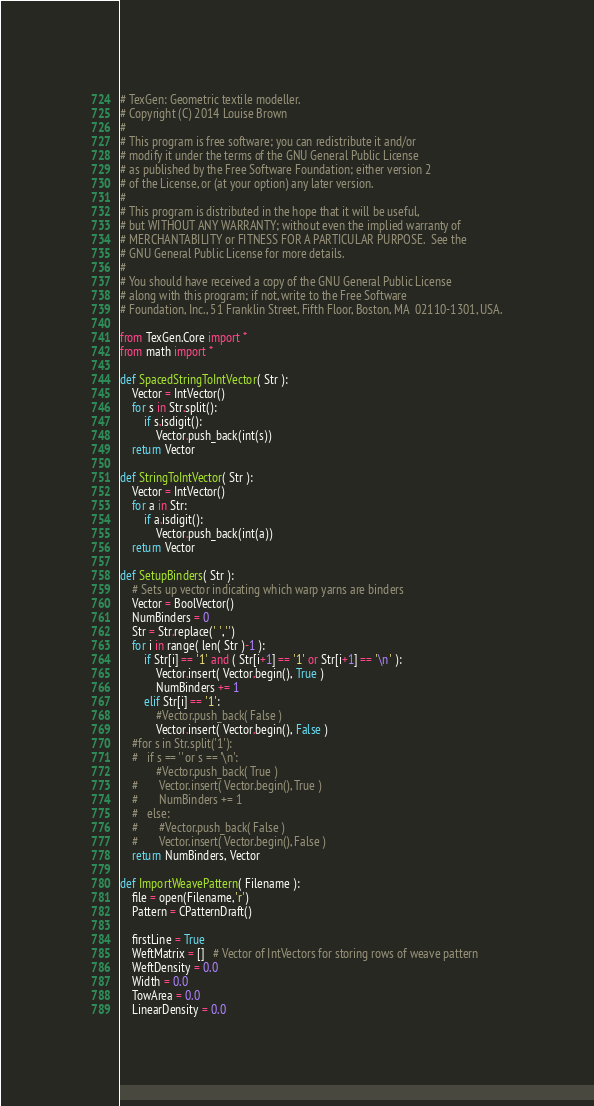Convert code to text. <code><loc_0><loc_0><loc_500><loc_500><_Python_># TexGen: Geometric textile modeller.
# Copyright (C) 2014 Louise Brown
# 
# This program is free software; you can redistribute it and/or
# modify it under the terms of the GNU General Public License
# as published by the Free Software Foundation; either version 2
# of the License, or (at your option) any later version.
# 
# This program is distributed in the hope that it will be useful,
# but WITHOUT ANY WARRANTY; without even the implied warranty of
# MERCHANTABILITY or FITNESS FOR A PARTICULAR PURPOSE.  See the
# GNU General Public License for more details.
# 
# You should have received a copy of the GNU General Public License
# along with this program; if not, write to the Free Software
# Foundation, Inc., 51 Franklin Street, Fifth Floor, Boston, MA  02110-1301, USA.

from TexGen.Core import *
from math import *

def SpacedStringToIntVector( Str ):
	Vector = IntVector()
	for s in Str.split():
		if s.isdigit():
			Vector.push_back(int(s))
	return Vector
	
def StringToIntVector( Str ):
	Vector = IntVector()
	for a in Str:
		if a.isdigit():
			Vector.push_back(int(a))
	return Vector
	
def SetupBinders( Str ):
    # Sets up vector indicating which warp yarns are binders
	Vector = BoolVector()
	NumBinders = 0
	Str = Str.replace(' ','')
	for i in range( len( Str )-1 ):
		if Str[i] == '1' and ( Str[i+1] == '1' or Str[i+1] == '\n' ):
			Vector.insert( Vector.begin(), True )
			NumBinders += 1
		elif Str[i] == '1':
			#Vector.push_back( False )
			Vector.insert( Vector.begin(), False )
	#for s in Str.split('1'):
	#	if s == '' or s == '\n':
			#Vector.push_back( True )
	#		Vector.insert( Vector.begin(), True )
	#		NumBinders += 1
	#	else:
	#		#Vector.push_back( False )
	#		Vector.insert( Vector.begin(), False )
	return NumBinders, Vector

def ImportWeavePattern( Filename ):
	file = open(Filename,'r')
	Pattern = CPatternDraft()

	firstLine = True
	WeftMatrix = []   # Vector of IntVectors for storing rows of weave pattern
	WeftDensity = 0.0
	Width = 0.0
	TowArea = 0.0
	LinearDensity = 0.0</code> 